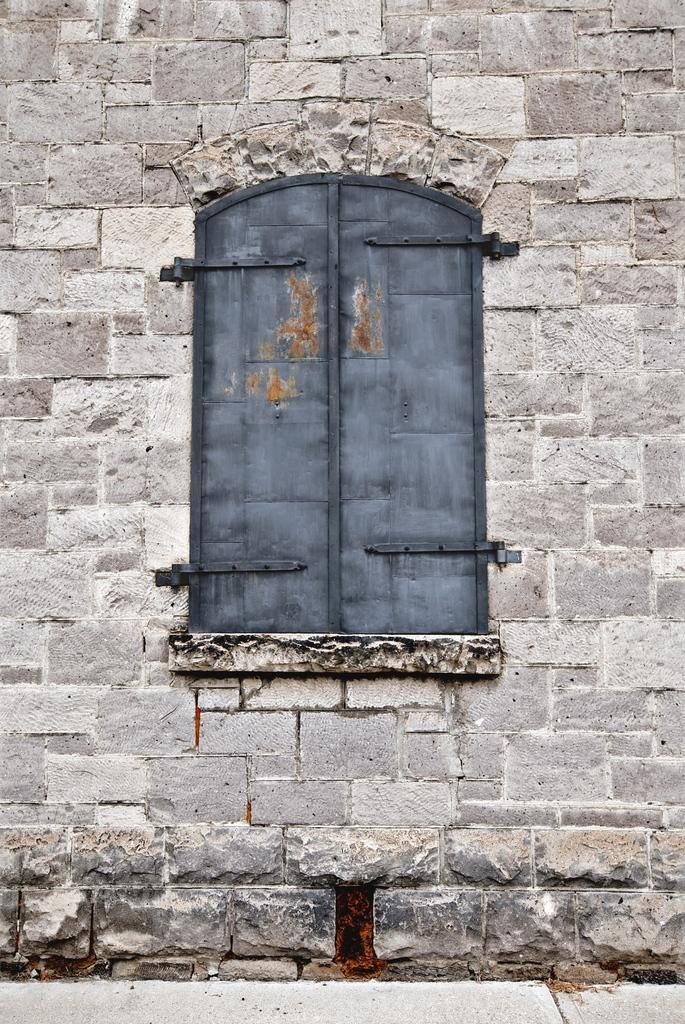What type of structure is depicted in the image? The image is of a building. Can you describe any specific features of the building? There is a wooden window in the building. What are the basic components of the building? The building has walls and a floor at the bottom. What type of crown is worn by the person standing in the alley next to the building? There is no person or alley present in the image, and therefore no crown can be observed. 